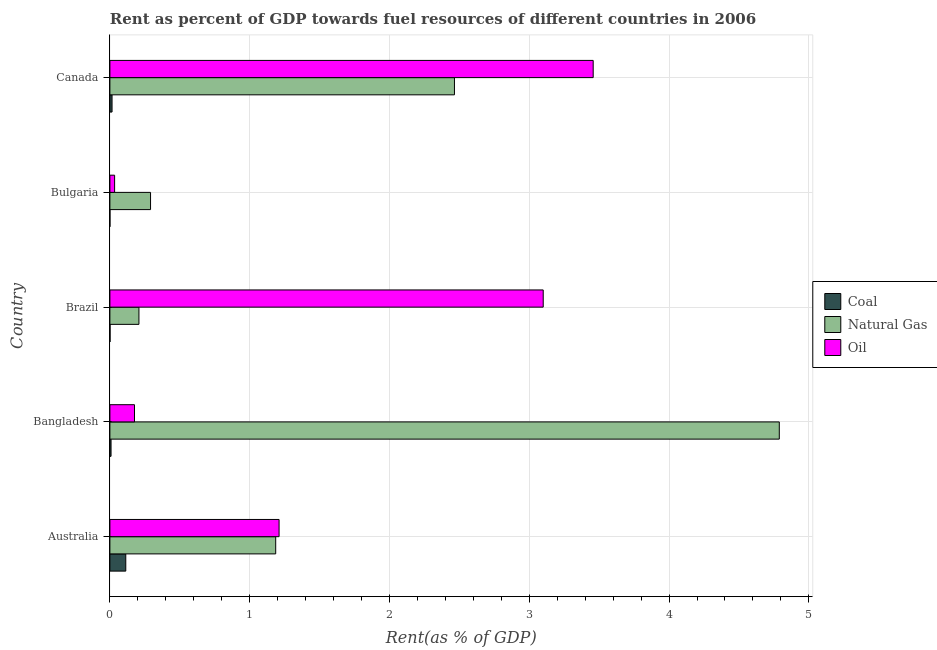How many different coloured bars are there?
Ensure brevity in your answer.  3. Are the number of bars on each tick of the Y-axis equal?
Keep it short and to the point. Yes. How many bars are there on the 4th tick from the bottom?
Give a very brief answer. 3. In how many cases, is the number of bars for a given country not equal to the number of legend labels?
Offer a very short reply. 0. What is the rent towards coal in Australia?
Provide a succinct answer. 0.11. Across all countries, what is the maximum rent towards natural gas?
Provide a succinct answer. 4.79. Across all countries, what is the minimum rent towards natural gas?
Ensure brevity in your answer.  0.21. What is the total rent towards oil in the graph?
Give a very brief answer. 7.98. What is the difference between the rent towards oil in Brazil and that in Canada?
Provide a short and direct response. -0.36. What is the difference between the rent towards oil in Bangladesh and the rent towards natural gas in Brazil?
Your answer should be very brief. -0.03. What is the average rent towards oil per country?
Your response must be concise. 1.59. What is the difference between the rent towards natural gas and rent towards oil in Bangladesh?
Your response must be concise. 4.61. In how many countries, is the rent towards natural gas greater than 2 %?
Provide a short and direct response. 2. What is the ratio of the rent towards oil in Bangladesh to that in Bulgaria?
Make the answer very short. 5.22. Is the difference between the rent towards coal in Bangladesh and Brazil greater than the difference between the rent towards oil in Bangladesh and Brazil?
Provide a succinct answer. Yes. What is the difference between the highest and the second highest rent towards oil?
Make the answer very short. 0.36. What is the difference between the highest and the lowest rent towards coal?
Make the answer very short. 0.11. In how many countries, is the rent towards coal greater than the average rent towards coal taken over all countries?
Make the answer very short. 1. What does the 3rd bar from the top in Bulgaria represents?
Ensure brevity in your answer.  Coal. What does the 2nd bar from the bottom in Canada represents?
Ensure brevity in your answer.  Natural Gas. Is it the case that in every country, the sum of the rent towards coal and rent towards natural gas is greater than the rent towards oil?
Offer a terse response. No. Does the graph contain grids?
Ensure brevity in your answer.  Yes. What is the title of the graph?
Keep it short and to the point. Rent as percent of GDP towards fuel resources of different countries in 2006. Does "Domestic" appear as one of the legend labels in the graph?
Provide a succinct answer. No. What is the label or title of the X-axis?
Your answer should be very brief. Rent(as % of GDP). What is the label or title of the Y-axis?
Your response must be concise. Country. What is the Rent(as % of GDP) of Coal in Australia?
Make the answer very short. 0.11. What is the Rent(as % of GDP) of Natural Gas in Australia?
Make the answer very short. 1.19. What is the Rent(as % of GDP) of Oil in Australia?
Offer a very short reply. 1.21. What is the Rent(as % of GDP) in Coal in Bangladesh?
Your answer should be compact. 0.01. What is the Rent(as % of GDP) in Natural Gas in Bangladesh?
Ensure brevity in your answer.  4.79. What is the Rent(as % of GDP) of Oil in Bangladesh?
Your answer should be very brief. 0.18. What is the Rent(as % of GDP) of Coal in Brazil?
Make the answer very short. 0. What is the Rent(as % of GDP) in Natural Gas in Brazil?
Give a very brief answer. 0.21. What is the Rent(as % of GDP) of Oil in Brazil?
Offer a very short reply. 3.1. What is the Rent(as % of GDP) in Coal in Bulgaria?
Give a very brief answer. 0. What is the Rent(as % of GDP) of Natural Gas in Bulgaria?
Make the answer very short. 0.29. What is the Rent(as % of GDP) in Oil in Bulgaria?
Your answer should be very brief. 0.03. What is the Rent(as % of GDP) in Coal in Canada?
Ensure brevity in your answer.  0.02. What is the Rent(as % of GDP) of Natural Gas in Canada?
Provide a short and direct response. 2.46. What is the Rent(as % of GDP) in Oil in Canada?
Give a very brief answer. 3.46. Across all countries, what is the maximum Rent(as % of GDP) of Coal?
Give a very brief answer. 0.11. Across all countries, what is the maximum Rent(as % of GDP) in Natural Gas?
Offer a terse response. 4.79. Across all countries, what is the maximum Rent(as % of GDP) in Oil?
Give a very brief answer. 3.46. Across all countries, what is the minimum Rent(as % of GDP) in Coal?
Offer a very short reply. 0. Across all countries, what is the minimum Rent(as % of GDP) in Natural Gas?
Offer a terse response. 0.21. Across all countries, what is the minimum Rent(as % of GDP) of Oil?
Make the answer very short. 0.03. What is the total Rent(as % of GDP) of Coal in the graph?
Your answer should be very brief. 0.14. What is the total Rent(as % of GDP) of Natural Gas in the graph?
Provide a succinct answer. 8.94. What is the total Rent(as % of GDP) of Oil in the graph?
Your answer should be very brief. 7.98. What is the difference between the Rent(as % of GDP) in Coal in Australia and that in Bangladesh?
Provide a short and direct response. 0.11. What is the difference between the Rent(as % of GDP) in Natural Gas in Australia and that in Bangladesh?
Your response must be concise. -3.6. What is the difference between the Rent(as % of GDP) in Oil in Australia and that in Bangladesh?
Offer a very short reply. 1.03. What is the difference between the Rent(as % of GDP) of Coal in Australia and that in Brazil?
Provide a short and direct response. 0.11. What is the difference between the Rent(as % of GDP) of Natural Gas in Australia and that in Brazil?
Offer a terse response. 0.98. What is the difference between the Rent(as % of GDP) of Oil in Australia and that in Brazil?
Your answer should be compact. -1.89. What is the difference between the Rent(as % of GDP) of Coal in Australia and that in Bulgaria?
Keep it short and to the point. 0.11. What is the difference between the Rent(as % of GDP) in Natural Gas in Australia and that in Bulgaria?
Your response must be concise. 0.9. What is the difference between the Rent(as % of GDP) in Oil in Australia and that in Bulgaria?
Provide a succinct answer. 1.18. What is the difference between the Rent(as % of GDP) of Coal in Australia and that in Canada?
Your response must be concise. 0.1. What is the difference between the Rent(as % of GDP) of Natural Gas in Australia and that in Canada?
Give a very brief answer. -1.28. What is the difference between the Rent(as % of GDP) in Oil in Australia and that in Canada?
Provide a short and direct response. -2.25. What is the difference between the Rent(as % of GDP) of Coal in Bangladesh and that in Brazil?
Your answer should be very brief. 0.01. What is the difference between the Rent(as % of GDP) of Natural Gas in Bangladesh and that in Brazil?
Your answer should be compact. 4.58. What is the difference between the Rent(as % of GDP) in Oil in Bangladesh and that in Brazil?
Your answer should be very brief. -2.92. What is the difference between the Rent(as % of GDP) of Coal in Bangladesh and that in Bulgaria?
Your answer should be compact. 0.01. What is the difference between the Rent(as % of GDP) of Natural Gas in Bangladesh and that in Bulgaria?
Provide a short and direct response. 4.5. What is the difference between the Rent(as % of GDP) of Oil in Bangladesh and that in Bulgaria?
Offer a very short reply. 0.14. What is the difference between the Rent(as % of GDP) of Coal in Bangladesh and that in Canada?
Offer a terse response. -0.01. What is the difference between the Rent(as % of GDP) of Natural Gas in Bangladesh and that in Canada?
Your answer should be compact. 2.32. What is the difference between the Rent(as % of GDP) of Oil in Bangladesh and that in Canada?
Give a very brief answer. -3.28. What is the difference between the Rent(as % of GDP) in Coal in Brazil and that in Bulgaria?
Make the answer very short. 0. What is the difference between the Rent(as % of GDP) in Natural Gas in Brazil and that in Bulgaria?
Give a very brief answer. -0.08. What is the difference between the Rent(as % of GDP) in Oil in Brazil and that in Bulgaria?
Give a very brief answer. 3.07. What is the difference between the Rent(as % of GDP) in Coal in Brazil and that in Canada?
Your answer should be very brief. -0.01. What is the difference between the Rent(as % of GDP) of Natural Gas in Brazil and that in Canada?
Provide a succinct answer. -2.26. What is the difference between the Rent(as % of GDP) in Oil in Brazil and that in Canada?
Provide a short and direct response. -0.36. What is the difference between the Rent(as % of GDP) in Coal in Bulgaria and that in Canada?
Ensure brevity in your answer.  -0.02. What is the difference between the Rent(as % of GDP) in Natural Gas in Bulgaria and that in Canada?
Ensure brevity in your answer.  -2.17. What is the difference between the Rent(as % of GDP) of Oil in Bulgaria and that in Canada?
Keep it short and to the point. -3.42. What is the difference between the Rent(as % of GDP) of Coal in Australia and the Rent(as % of GDP) of Natural Gas in Bangladesh?
Offer a very short reply. -4.67. What is the difference between the Rent(as % of GDP) of Coal in Australia and the Rent(as % of GDP) of Oil in Bangladesh?
Offer a terse response. -0.06. What is the difference between the Rent(as % of GDP) of Natural Gas in Australia and the Rent(as % of GDP) of Oil in Bangladesh?
Your answer should be very brief. 1.01. What is the difference between the Rent(as % of GDP) of Coal in Australia and the Rent(as % of GDP) of Natural Gas in Brazil?
Your answer should be very brief. -0.09. What is the difference between the Rent(as % of GDP) of Coal in Australia and the Rent(as % of GDP) of Oil in Brazil?
Provide a succinct answer. -2.99. What is the difference between the Rent(as % of GDP) of Natural Gas in Australia and the Rent(as % of GDP) of Oil in Brazil?
Offer a very short reply. -1.91. What is the difference between the Rent(as % of GDP) in Coal in Australia and the Rent(as % of GDP) in Natural Gas in Bulgaria?
Your response must be concise. -0.18. What is the difference between the Rent(as % of GDP) in Coal in Australia and the Rent(as % of GDP) in Oil in Bulgaria?
Your answer should be very brief. 0.08. What is the difference between the Rent(as % of GDP) in Natural Gas in Australia and the Rent(as % of GDP) in Oil in Bulgaria?
Ensure brevity in your answer.  1.15. What is the difference between the Rent(as % of GDP) of Coal in Australia and the Rent(as % of GDP) of Natural Gas in Canada?
Your response must be concise. -2.35. What is the difference between the Rent(as % of GDP) in Coal in Australia and the Rent(as % of GDP) in Oil in Canada?
Your answer should be compact. -3.34. What is the difference between the Rent(as % of GDP) of Natural Gas in Australia and the Rent(as % of GDP) of Oil in Canada?
Make the answer very short. -2.27. What is the difference between the Rent(as % of GDP) in Coal in Bangladesh and the Rent(as % of GDP) in Natural Gas in Brazil?
Provide a succinct answer. -0.2. What is the difference between the Rent(as % of GDP) of Coal in Bangladesh and the Rent(as % of GDP) of Oil in Brazil?
Your response must be concise. -3.09. What is the difference between the Rent(as % of GDP) in Natural Gas in Bangladesh and the Rent(as % of GDP) in Oil in Brazil?
Offer a terse response. 1.69. What is the difference between the Rent(as % of GDP) of Coal in Bangladesh and the Rent(as % of GDP) of Natural Gas in Bulgaria?
Offer a terse response. -0.28. What is the difference between the Rent(as % of GDP) of Coal in Bangladesh and the Rent(as % of GDP) of Oil in Bulgaria?
Your answer should be compact. -0.03. What is the difference between the Rent(as % of GDP) in Natural Gas in Bangladesh and the Rent(as % of GDP) in Oil in Bulgaria?
Offer a terse response. 4.75. What is the difference between the Rent(as % of GDP) in Coal in Bangladesh and the Rent(as % of GDP) in Natural Gas in Canada?
Offer a very short reply. -2.46. What is the difference between the Rent(as % of GDP) in Coal in Bangladesh and the Rent(as % of GDP) in Oil in Canada?
Provide a succinct answer. -3.45. What is the difference between the Rent(as % of GDP) in Natural Gas in Bangladesh and the Rent(as % of GDP) in Oil in Canada?
Give a very brief answer. 1.33. What is the difference between the Rent(as % of GDP) in Coal in Brazil and the Rent(as % of GDP) in Natural Gas in Bulgaria?
Provide a short and direct response. -0.29. What is the difference between the Rent(as % of GDP) in Coal in Brazil and the Rent(as % of GDP) in Oil in Bulgaria?
Provide a succinct answer. -0.03. What is the difference between the Rent(as % of GDP) in Natural Gas in Brazil and the Rent(as % of GDP) in Oil in Bulgaria?
Your answer should be very brief. 0.17. What is the difference between the Rent(as % of GDP) in Coal in Brazil and the Rent(as % of GDP) in Natural Gas in Canada?
Your answer should be very brief. -2.46. What is the difference between the Rent(as % of GDP) in Coal in Brazil and the Rent(as % of GDP) in Oil in Canada?
Give a very brief answer. -3.46. What is the difference between the Rent(as % of GDP) of Natural Gas in Brazil and the Rent(as % of GDP) of Oil in Canada?
Ensure brevity in your answer.  -3.25. What is the difference between the Rent(as % of GDP) of Coal in Bulgaria and the Rent(as % of GDP) of Natural Gas in Canada?
Provide a short and direct response. -2.46. What is the difference between the Rent(as % of GDP) of Coal in Bulgaria and the Rent(as % of GDP) of Oil in Canada?
Offer a very short reply. -3.46. What is the difference between the Rent(as % of GDP) in Natural Gas in Bulgaria and the Rent(as % of GDP) in Oil in Canada?
Your answer should be very brief. -3.17. What is the average Rent(as % of GDP) of Coal per country?
Keep it short and to the point. 0.03. What is the average Rent(as % of GDP) of Natural Gas per country?
Make the answer very short. 1.79. What is the average Rent(as % of GDP) of Oil per country?
Your answer should be very brief. 1.6. What is the difference between the Rent(as % of GDP) of Coal and Rent(as % of GDP) of Natural Gas in Australia?
Your answer should be compact. -1.07. What is the difference between the Rent(as % of GDP) in Coal and Rent(as % of GDP) in Oil in Australia?
Provide a short and direct response. -1.1. What is the difference between the Rent(as % of GDP) of Natural Gas and Rent(as % of GDP) of Oil in Australia?
Provide a short and direct response. -0.02. What is the difference between the Rent(as % of GDP) of Coal and Rent(as % of GDP) of Natural Gas in Bangladesh?
Provide a succinct answer. -4.78. What is the difference between the Rent(as % of GDP) of Coal and Rent(as % of GDP) of Oil in Bangladesh?
Provide a succinct answer. -0.17. What is the difference between the Rent(as % of GDP) of Natural Gas and Rent(as % of GDP) of Oil in Bangladesh?
Ensure brevity in your answer.  4.61. What is the difference between the Rent(as % of GDP) in Coal and Rent(as % of GDP) in Natural Gas in Brazil?
Provide a short and direct response. -0.21. What is the difference between the Rent(as % of GDP) of Coal and Rent(as % of GDP) of Oil in Brazil?
Make the answer very short. -3.1. What is the difference between the Rent(as % of GDP) in Natural Gas and Rent(as % of GDP) in Oil in Brazil?
Give a very brief answer. -2.89. What is the difference between the Rent(as % of GDP) of Coal and Rent(as % of GDP) of Natural Gas in Bulgaria?
Provide a succinct answer. -0.29. What is the difference between the Rent(as % of GDP) in Coal and Rent(as % of GDP) in Oil in Bulgaria?
Provide a succinct answer. -0.03. What is the difference between the Rent(as % of GDP) in Natural Gas and Rent(as % of GDP) in Oil in Bulgaria?
Ensure brevity in your answer.  0.26. What is the difference between the Rent(as % of GDP) of Coal and Rent(as % of GDP) of Natural Gas in Canada?
Make the answer very short. -2.45. What is the difference between the Rent(as % of GDP) of Coal and Rent(as % of GDP) of Oil in Canada?
Make the answer very short. -3.44. What is the difference between the Rent(as % of GDP) in Natural Gas and Rent(as % of GDP) in Oil in Canada?
Give a very brief answer. -0.99. What is the ratio of the Rent(as % of GDP) in Coal in Australia to that in Bangladesh?
Give a very brief answer. 13.82. What is the ratio of the Rent(as % of GDP) of Natural Gas in Australia to that in Bangladesh?
Your answer should be very brief. 0.25. What is the ratio of the Rent(as % of GDP) in Oil in Australia to that in Bangladesh?
Offer a terse response. 6.88. What is the ratio of the Rent(as % of GDP) of Coal in Australia to that in Brazil?
Provide a short and direct response. 99.22. What is the ratio of the Rent(as % of GDP) of Natural Gas in Australia to that in Brazil?
Your response must be concise. 5.71. What is the ratio of the Rent(as % of GDP) in Oil in Australia to that in Brazil?
Ensure brevity in your answer.  0.39. What is the ratio of the Rent(as % of GDP) of Coal in Australia to that in Bulgaria?
Provide a short and direct response. 402.54. What is the ratio of the Rent(as % of GDP) in Natural Gas in Australia to that in Bulgaria?
Keep it short and to the point. 4.08. What is the ratio of the Rent(as % of GDP) in Oil in Australia to that in Bulgaria?
Offer a very short reply. 35.88. What is the ratio of the Rent(as % of GDP) in Coal in Australia to that in Canada?
Provide a short and direct response. 7.35. What is the ratio of the Rent(as % of GDP) in Natural Gas in Australia to that in Canada?
Offer a terse response. 0.48. What is the ratio of the Rent(as % of GDP) of Oil in Australia to that in Canada?
Your answer should be very brief. 0.35. What is the ratio of the Rent(as % of GDP) of Coal in Bangladesh to that in Brazil?
Ensure brevity in your answer.  7.18. What is the ratio of the Rent(as % of GDP) of Natural Gas in Bangladesh to that in Brazil?
Your answer should be compact. 23.04. What is the ratio of the Rent(as % of GDP) of Oil in Bangladesh to that in Brazil?
Keep it short and to the point. 0.06. What is the ratio of the Rent(as % of GDP) in Coal in Bangladesh to that in Bulgaria?
Give a very brief answer. 29.14. What is the ratio of the Rent(as % of GDP) of Natural Gas in Bangladesh to that in Bulgaria?
Your answer should be compact. 16.47. What is the ratio of the Rent(as % of GDP) in Oil in Bangladesh to that in Bulgaria?
Offer a terse response. 5.22. What is the ratio of the Rent(as % of GDP) in Coal in Bangladesh to that in Canada?
Your answer should be very brief. 0.53. What is the ratio of the Rent(as % of GDP) of Natural Gas in Bangladesh to that in Canada?
Keep it short and to the point. 1.94. What is the ratio of the Rent(as % of GDP) in Oil in Bangladesh to that in Canada?
Your answer should be compact. 0.05. What is the ratio of the Rent(as % of GDP) in Coal in Brazil to that in Bulgaria?
Your response must be concise. 4.06. What is the ratio of the Rent(as % of GDP) in Natural Gas in Brazil to that in Bulgaria?
Provide a short and direct response. 0.71. What is the ratio of the Rent(as % of GDP) in Oil in Brazil to that in Bulgaria?
Make the answer very short. 91.89. What is the ratio of the Rent(as % of GDP) of Coal in Brazil to that in Canada?
Provide a succinct answer. 0.07. What is the ratio of the Rent(as % of GDP) in Natural Gas in Brazil to that in Canada?
Your answer should be very brief. 0.08. What is the ratio of the Rent(as % of GDP) of Oil in Brazil to that in Canada?
Make the answer very short. 0.9. What is the ratio of the Rent(as % of GDP) of Coal in Bulgaria to that in Canada?
Make the answer very short. 0.02. What is the ratio of the Rent(as % of GDP) in Natural Gas in Bulgaria to that in Canada?
Your answer should be very brief. 0.12. What is the ratio of the Rent(as % of GDP) of Oil in Bulgaria to that in Canada?
Give a very brief answer. 0.01. What is the difference between the highest and the second highest Rent(as % of GDP) in Coal?
Provide a short and direct response. 0.1. What is the difference between the highest and the second highest Rent(as % of GDP) of Natural Gas?
Give a very brief answer. 2.32. What is the difference between the highest and the second highest Rent(as % of GDP) of Oil?
Your response must be concise. 0.36. What is the difference between the highest and the lowest Rent(as % of GDP) of Coal?
Give a very brief answer. 0.11. What is the difference between the highest and the lowest Rent(as % of GDP) of Natural Gas?
Provide a succinct answer. 4.58. What is the difference between the highest and the lowest Rent(as % of GDP) in Oil?
Keep it short and to the point. 3.42. 